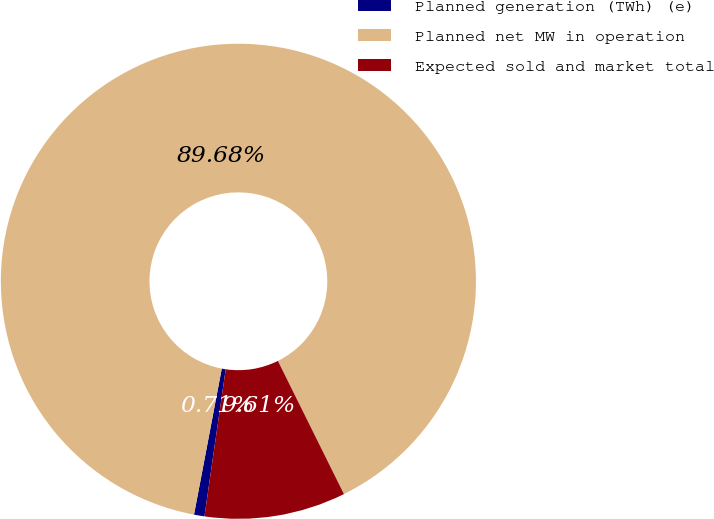<chart> <loc_0><loc_0><loc_500><loc_500><pie_chart><fcel>Planned generation (TWh) (e)<fcel>Planned net MW in operation<fcel>Expected sold and market total<nl><fcel>0.71%<fcel>89.68%<fcel>9.61%<nl></chart> 